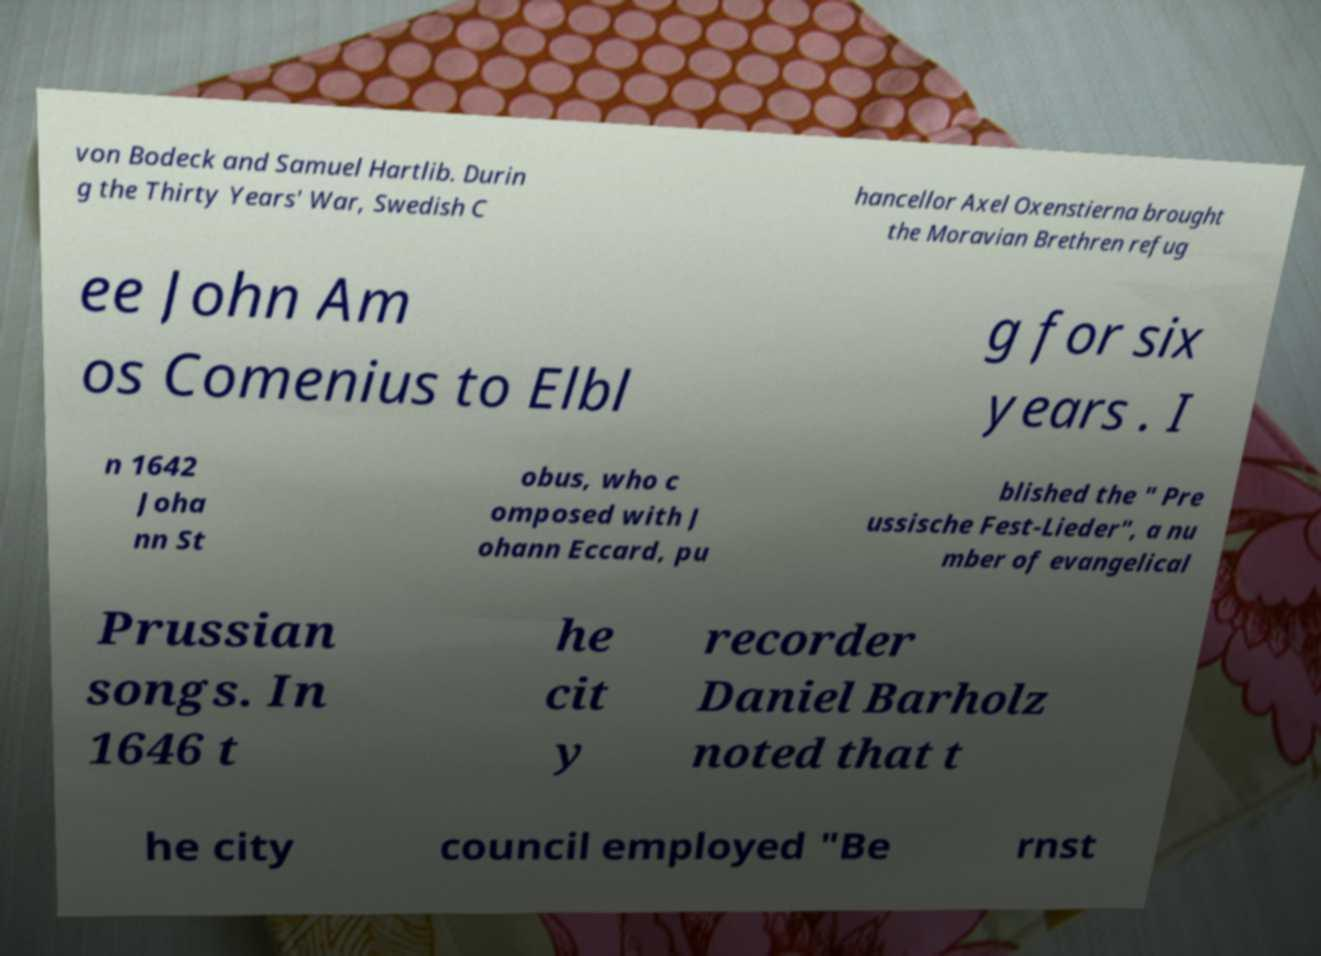For documentation purposes, I need the text within this image transcribed. Could you provide that? von Bodeck and Samuel Hartlib. Durin g the Thirty Years' War, Swedish C hancellor Axel Oxenstierna brought the Moravian Brethren refug ee John Am os Comenius to Elbl g for six years . I n 1642 Joha nn St obus, who c omposed with J ohann Eccard, pu blished the " Pre ussische Fest-Lieder", a nu mber of evangelical Prussian songs. In 1646 t he cit y recorder Daniel Barholz noted that t he city council employed "Be rnst 